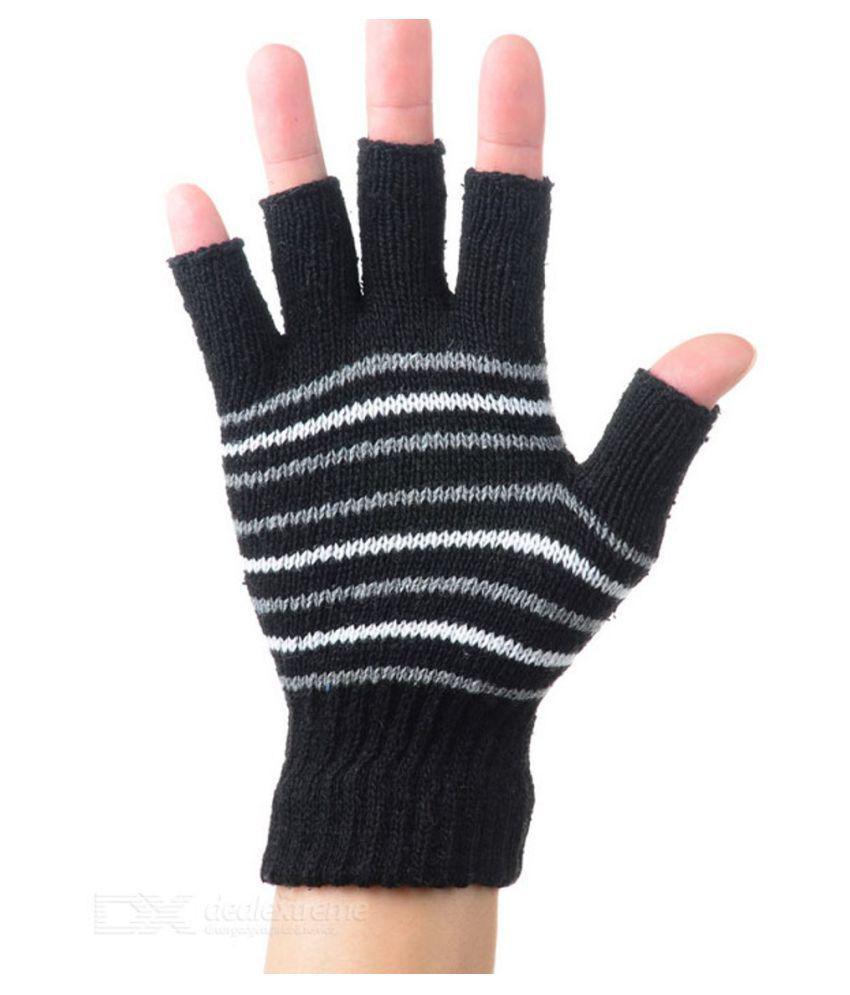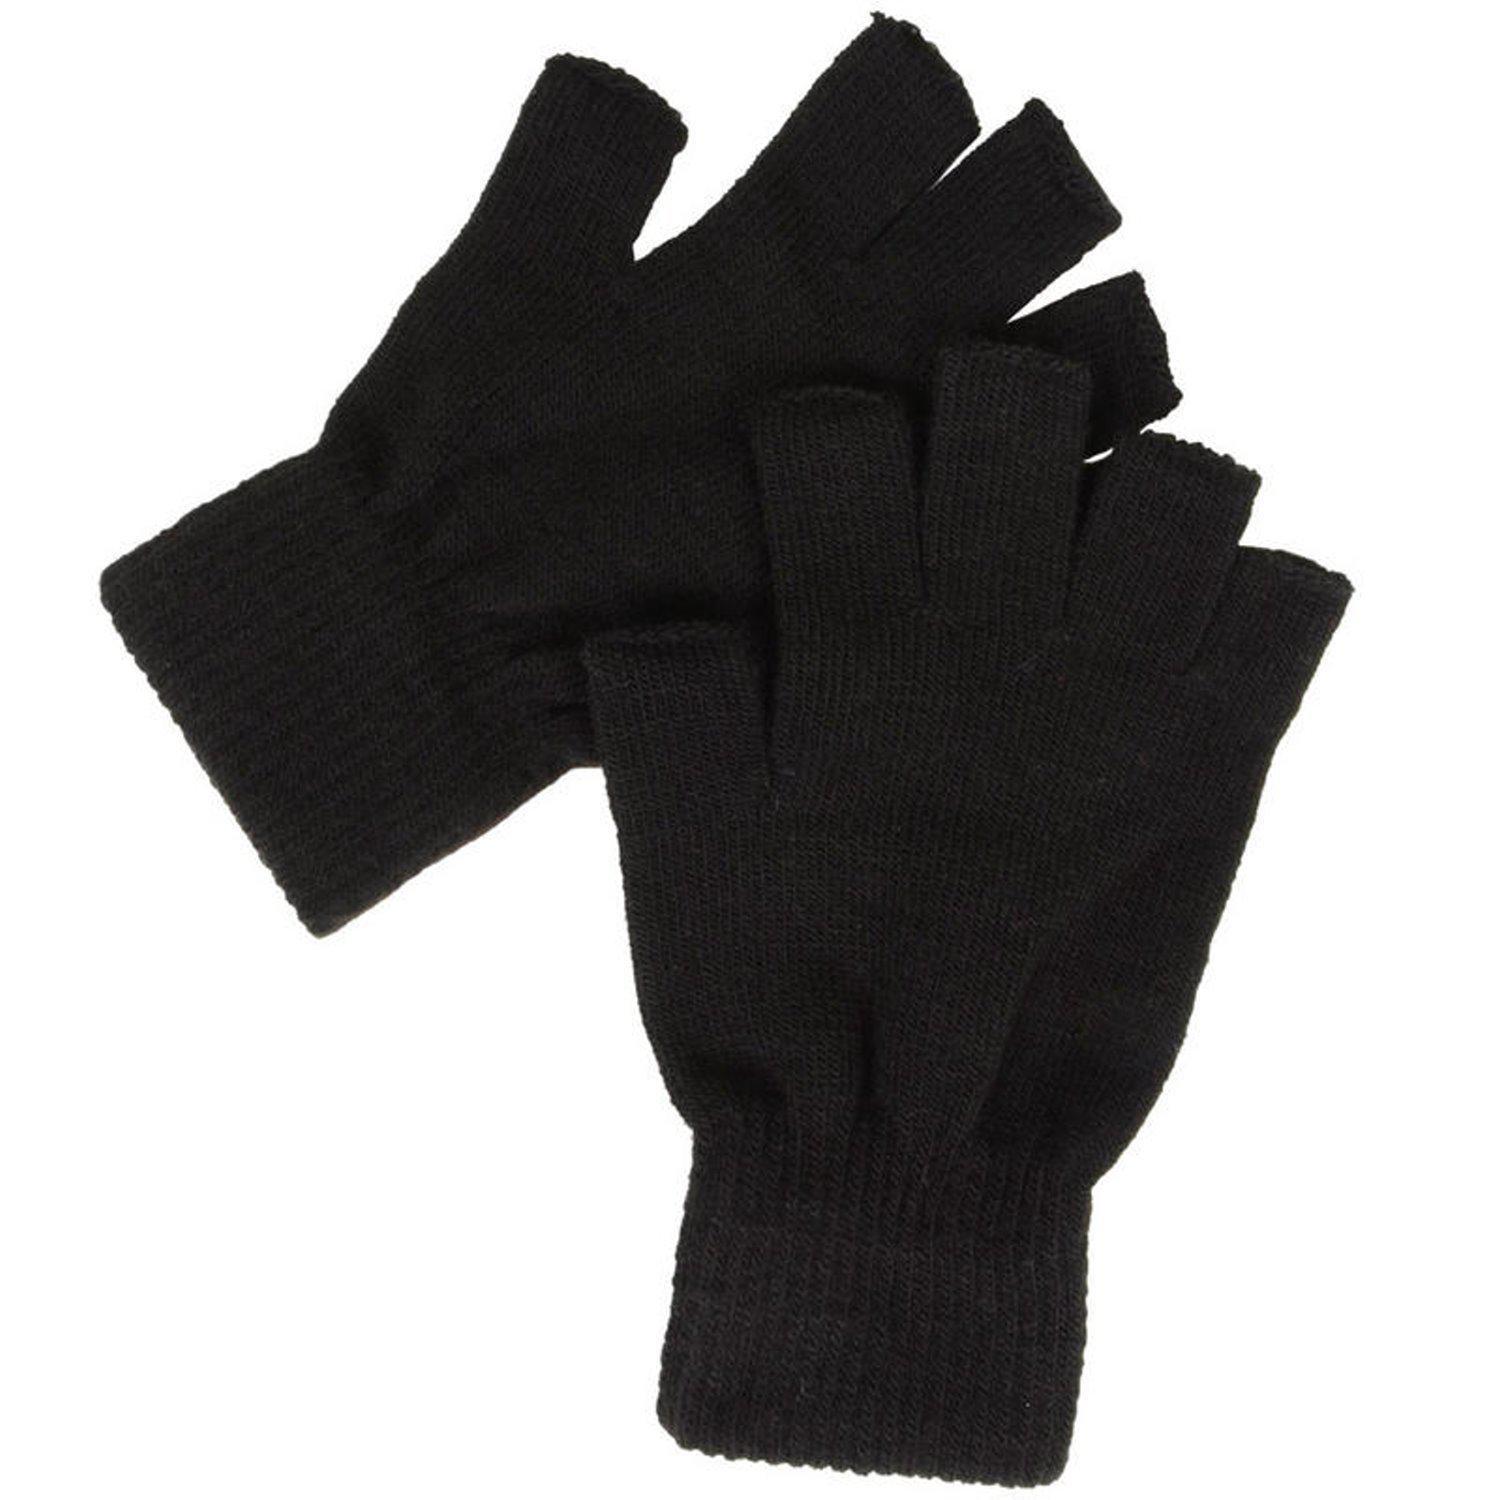The first image is the image on the left, the second image is the image on the right. Evaluate the accuracy of this statement regarding the images: "One image shows a pair of dark half-finger gloves, and the other image shows a single knitted half-finger glove with a striped pattern.". Is it true? Answer yes or no. Yes. The first image is the image on the left, the second image is the image on the right. Assess this claim about the two images: "A glove is on a single hand in the image on the left.". Correct or not? Answer yes or no. Yes. 